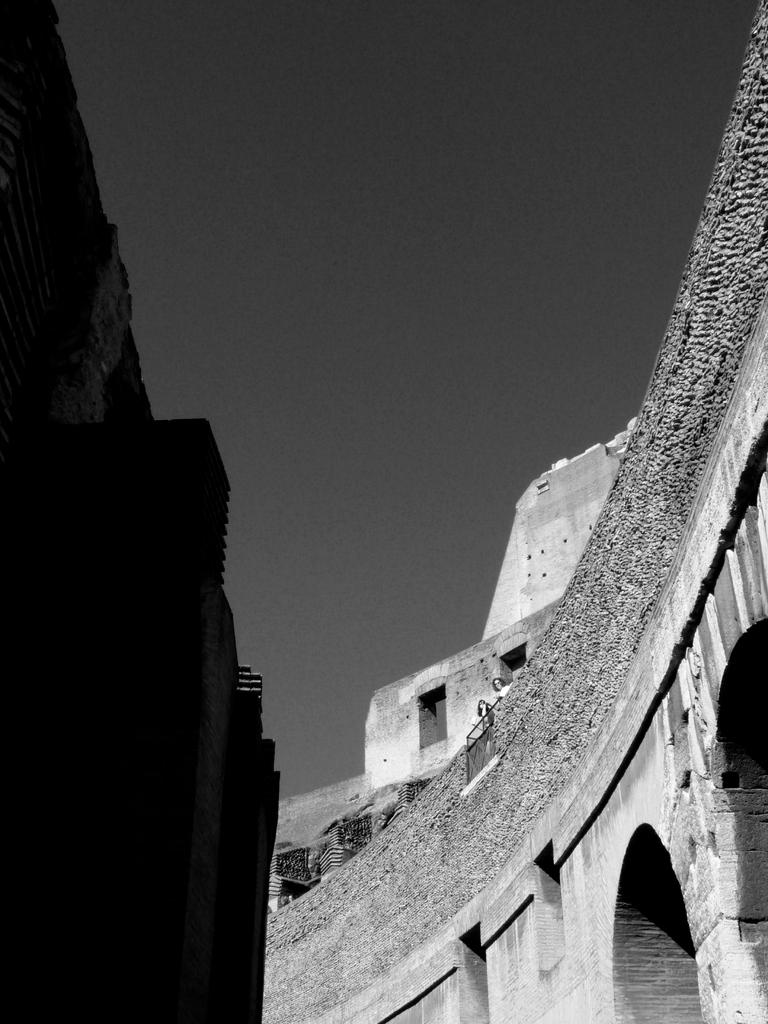Where was the picture taken? The picture was taken outside. What can be seen in the center of the image? There are buildings in the center of the image. What is visible in the background of the image? The sky is visible in the background of the image. What degree of smoke can be seen coming from the chimneys of the buildings in the image? There is no smoke visible in the image, as the buildings do not have chimneys. 